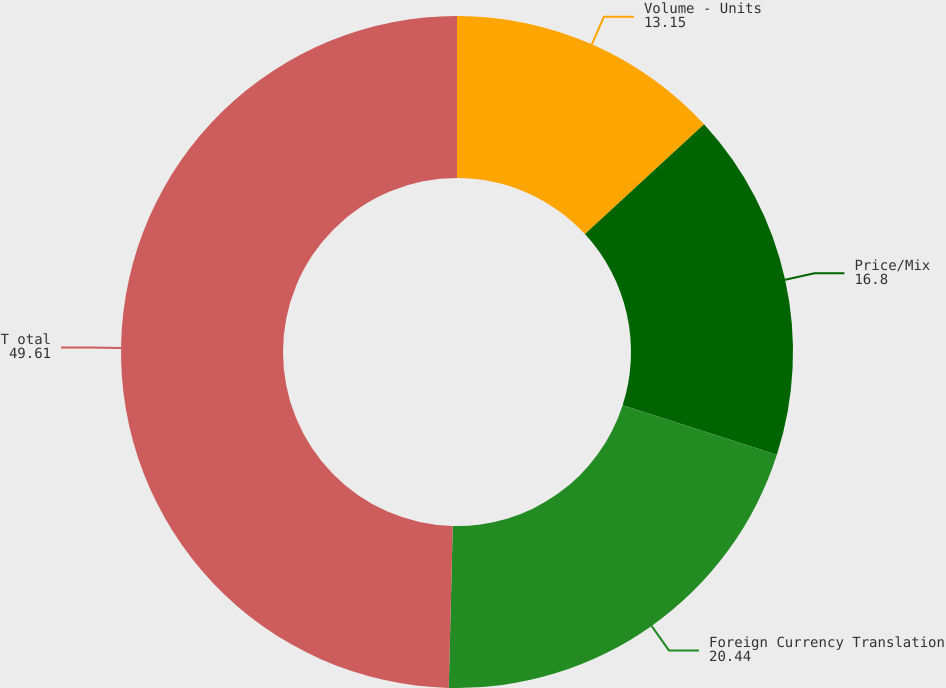Convert chart. <chart><loc_0><loc_0><loc_500><loc_500><pie_chart><fcel>Volume - Units<fcel>Price/Mix<fcel>Foreign Currency Translation<fcel>T otal<nl><fcel>13.15%<fcel>16.8%<fcel>20.44%<fcel>49.61%<nl></chart> 